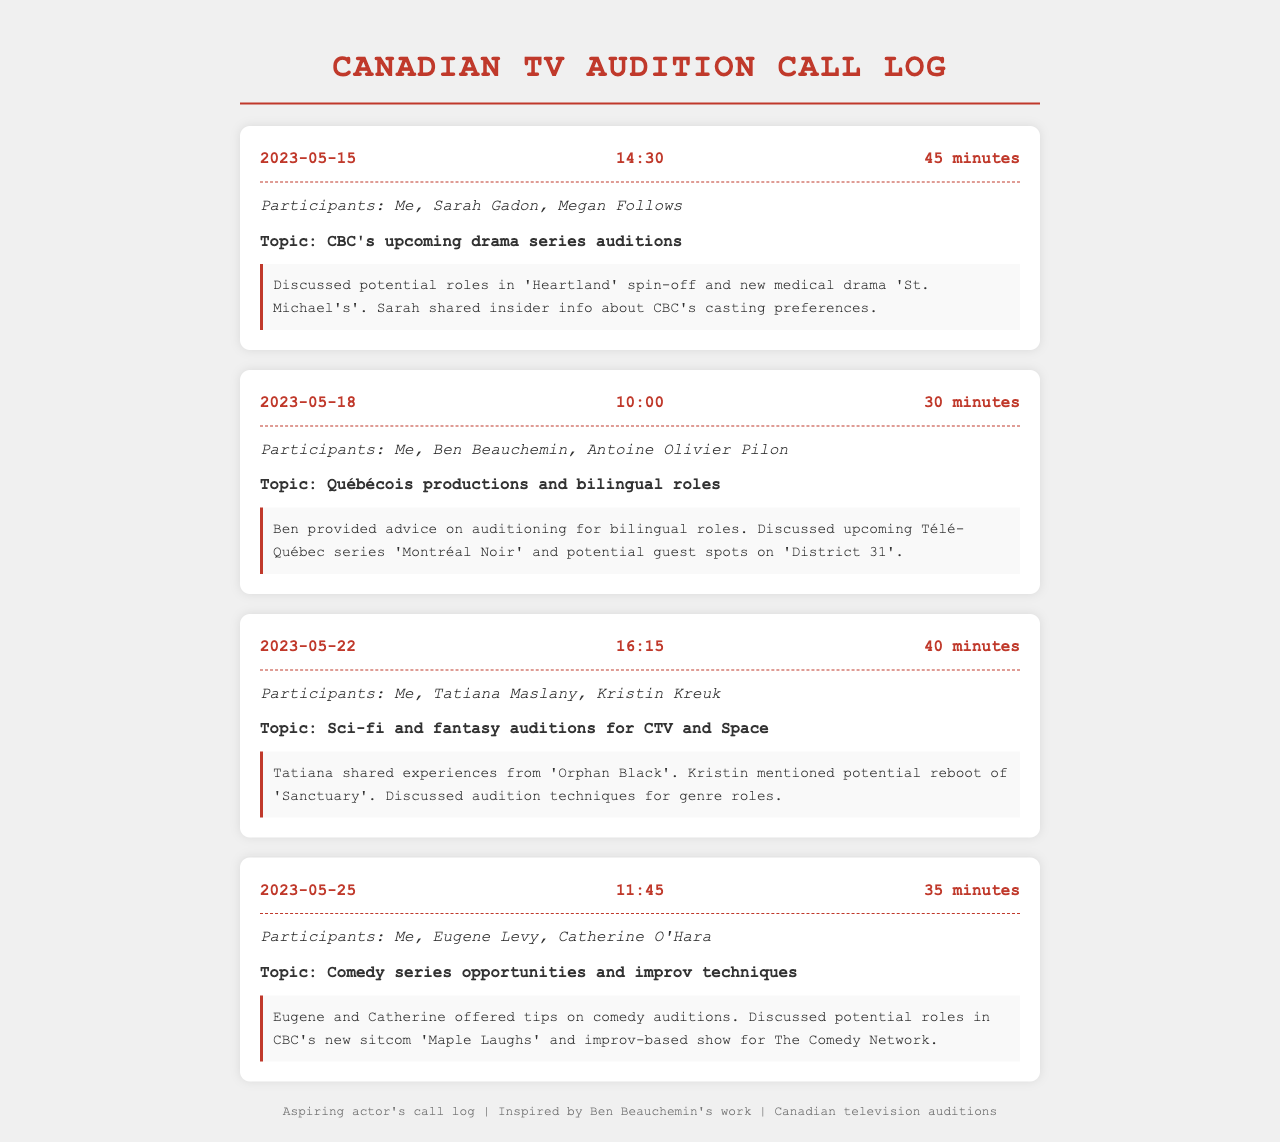What date did the call with Sarah Gadon take place? The call with Sarah Gadon occurred on 2023-05-15, as noted in the document.
Answer: 2023-05-15 Who participated in the call on May 18? The participants in the call on May 18 were Me, Ben Beauchemin, and Antoine Olivier Pilon.
Answer: Me, Ben Beauchemin, Antoine Olivier Pilon What was the duration of the call on May 25? The call on May 25 lasted 35 minutes, which is mentioned in the call log.
Answer: 35 minutes What topic did Tatiana Maslany discuss during her call? Tatiana Maslany discussed auditions for sci-fi and fantasy shows on CTV and Space, as stated in the document.
Answer: Sci-fi and fantasy auditions for CTV and Space How many calls were logged in total? There were four calls logged in the document, as detailed in the call entries.
Answer: Four What advice did Ben give about auditioning? Ben provided advice on auditioning for bilingual roles, according to the call notes.
Answer: Bilingual roles What series was mentioned during the call with Eugene Levy? The series mentioned during the call with Eugene Levy was "Maple Laughs," as indicated in the call notes.
Answer: Maple Laughs Which participant shared experiences from 'Orphan Black'? Tatiana Maslany shared her experiences from 'Orphan Black,' as noted in the call with her.
Answer: Tatiana Maslany 